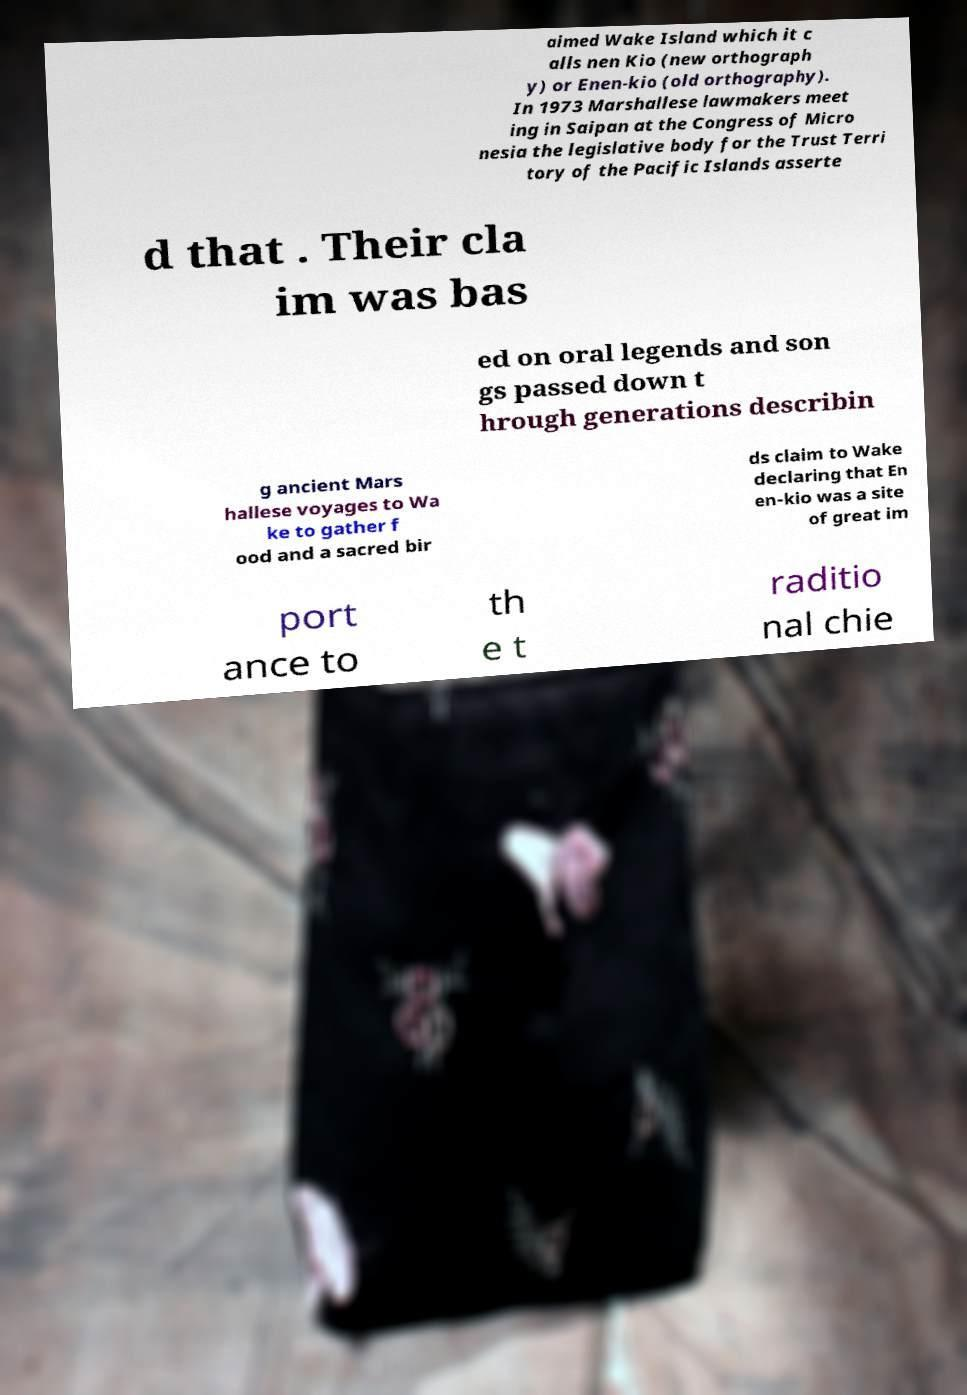Please read and relay the text visible in this image. What does it say? aimed Wake Island which it c alls nen Kio (new orthograph y) or Enen-kio (old orthography). In 1973 Marshallese lawmakers meet ing in Saipan at the Congress of Micro nesia the legislative body for the Trust Terri tory of the Pacific Islands asserte d that . Their cla im was bas ed on oral legends and son gs passed down t hrough generations describin g ancient Mars hallese voyages to Wa ke to gather f ood and a sacred bir ds claim to Wake declaring that En en-kio was a site of great im port ance to th e t raditio nal chie 